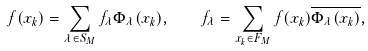<formula> <loc_0><loc_0><loc_500><loc_500>f ( x _ { k } ) = \sum _ { \lambda \in S _ { M } } f _ { \lambda } \Phi _ { \lambda } ( x _ { k } ) , \quad f _ { \lambda } = \sum _ { x _ { k } \in F _ { M } } f ( x _ { k } ) \overline { \Phi _ { \lambda } ( x _ { k } ) } ,</formula> 